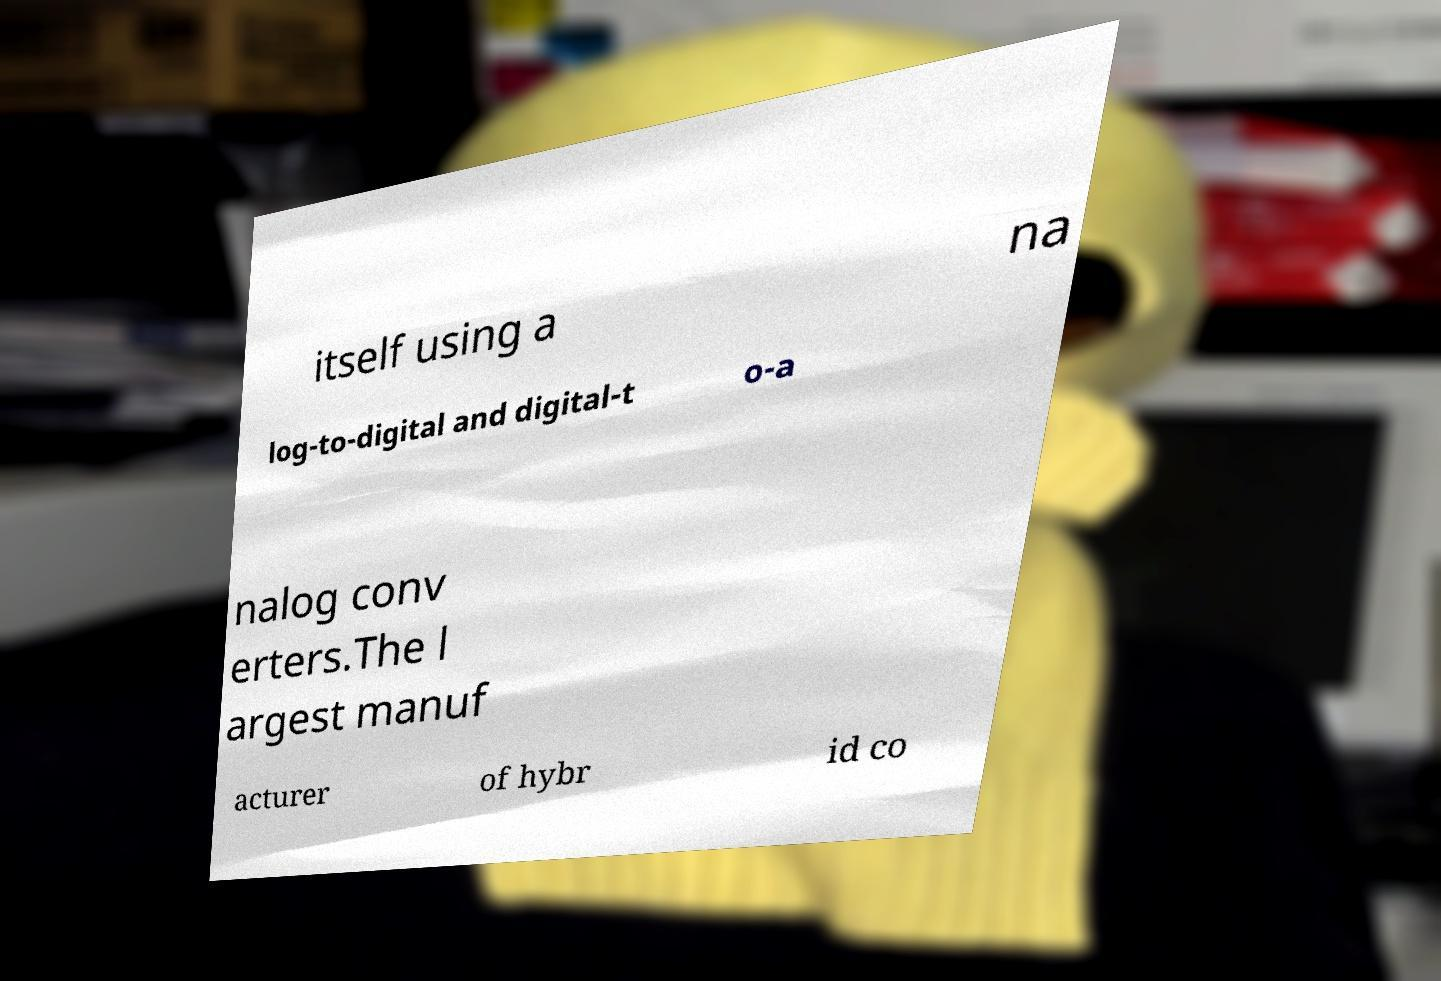Could you assist in decoding the text presented in this image and type it out clearly? itself using a na log-to-digital and digital-t o-a nalog conv erters.The l argest manuf acturer of hybr id co 